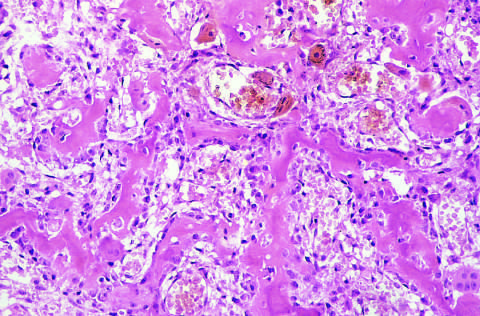re the alveoli filled by vascularized loose connective tissue?
Answer the question using a single word or phrase. No 